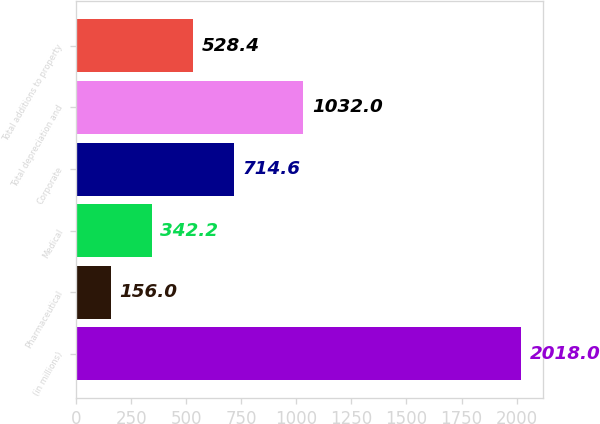Convert chart to OTSL. <chart><loc_0><loc_0><loc_500><loc_500><bar_chart><fcel>(in millions)<fcel>Pharmaceutical<fcel>Medical<fcel>Corporate<fcel>Total depreciation and<fcel>Total additions to property<nl><fcel>2018<fcel>156<fcel>342.2<fcel>714.6<fcel>1032<fcel>528.4<nl></chart> 